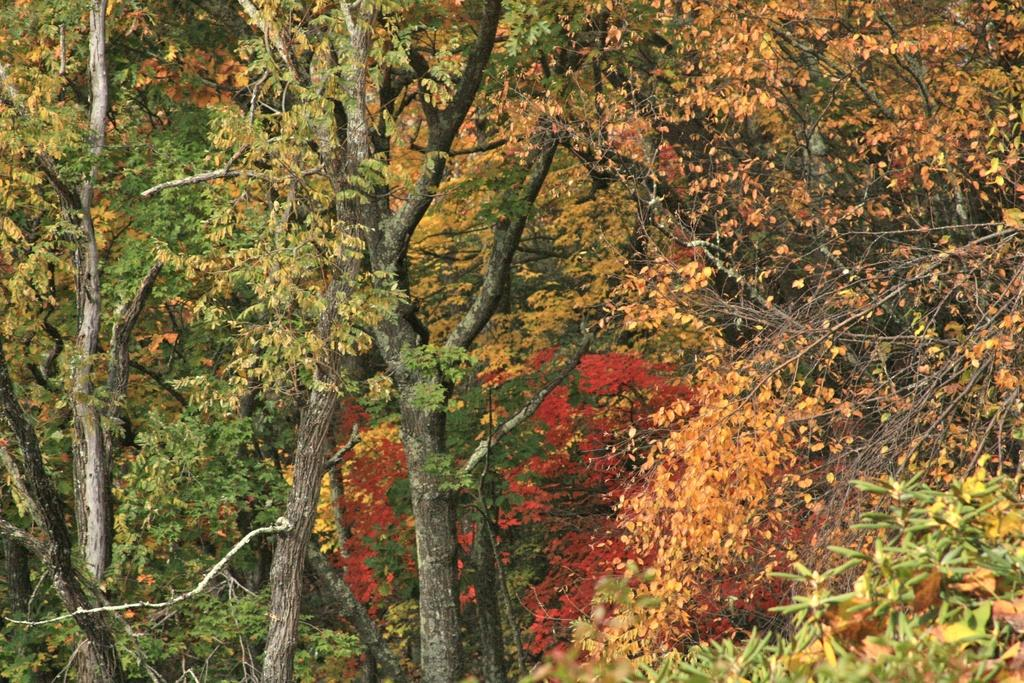What type of vegetation can be seen in the image? There are trees in the image. What type of ant can be seen crawling on the stage in the image? There is no stage or ant present in the image; it only features trees. 